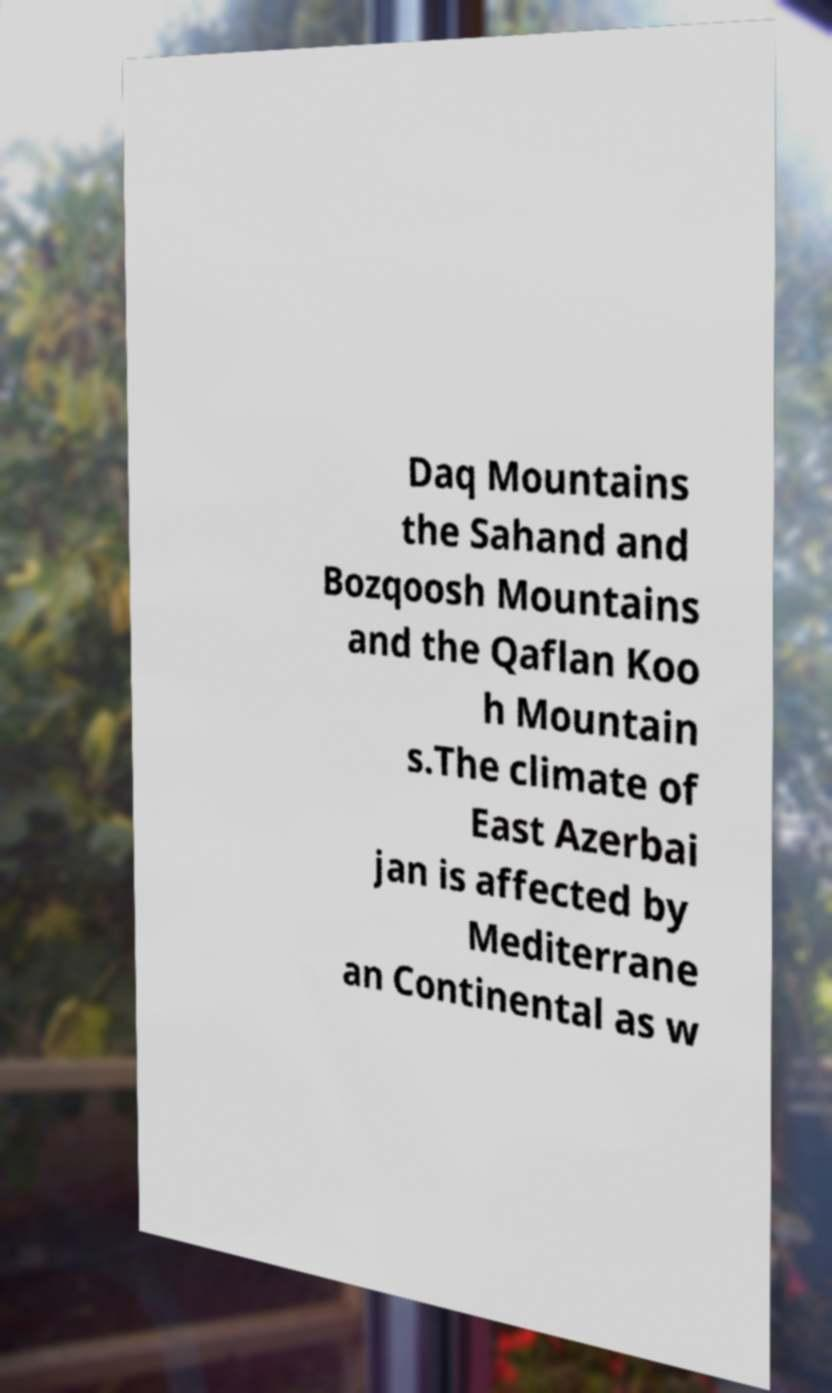I need the written content from this picture converted into text. Can you do that? Daq Mountains the Sahand and Bozqoosh Mountains and the Qaflan Koo h Mountain s.The climate of East Azerbai jan is affected by Mediterrane an Continental as w 